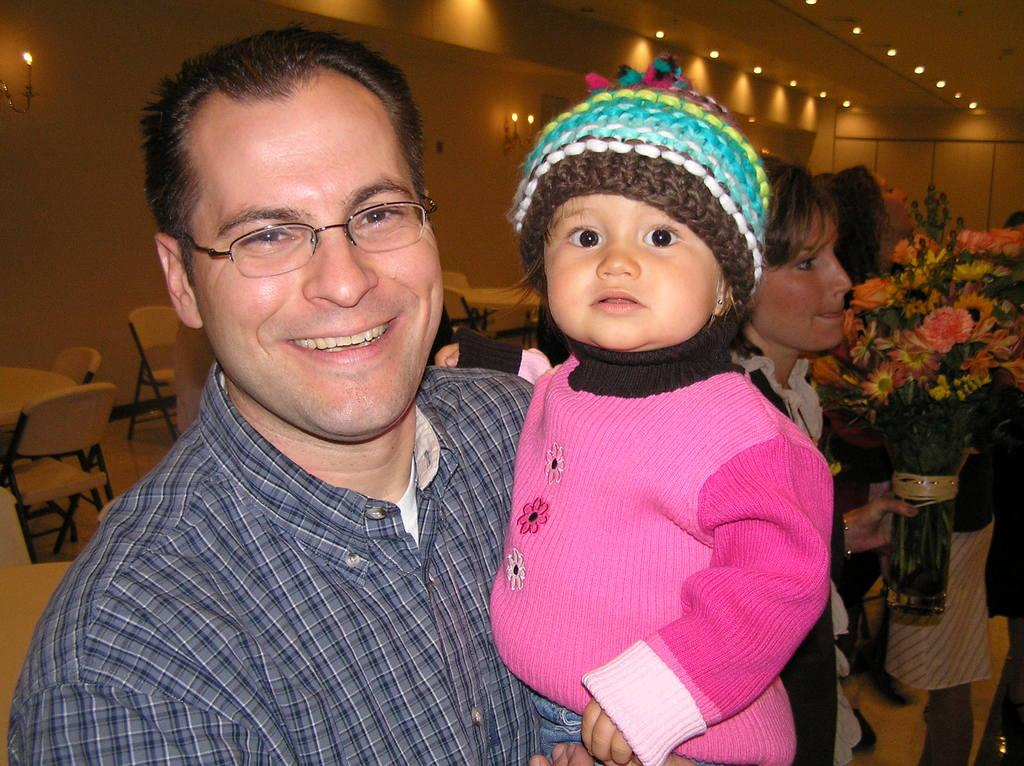What is the person in the image doing with the baby? The person is holding a baby in the image. What is the facial expression of the person holding the baby? The person is smiling. Who else is present in the image besides the person holding the baby? There is a woman with a flower bouquet in the image. What type of furniture is visible in the image? Tables and chairs are present in the image. What type of truck is parked near the library in the image? There is no truck or library present in the image. 